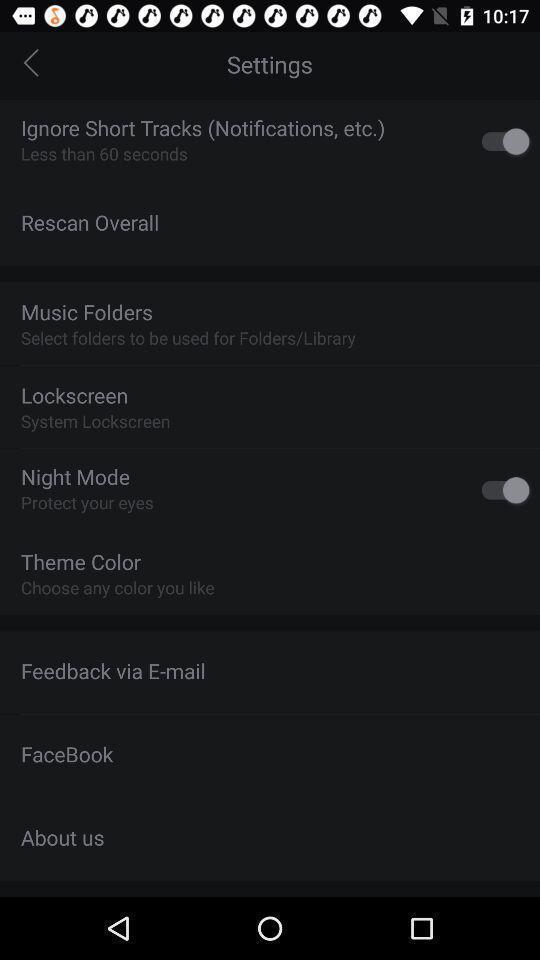What details can you identify in this image? Settings page displaying. 